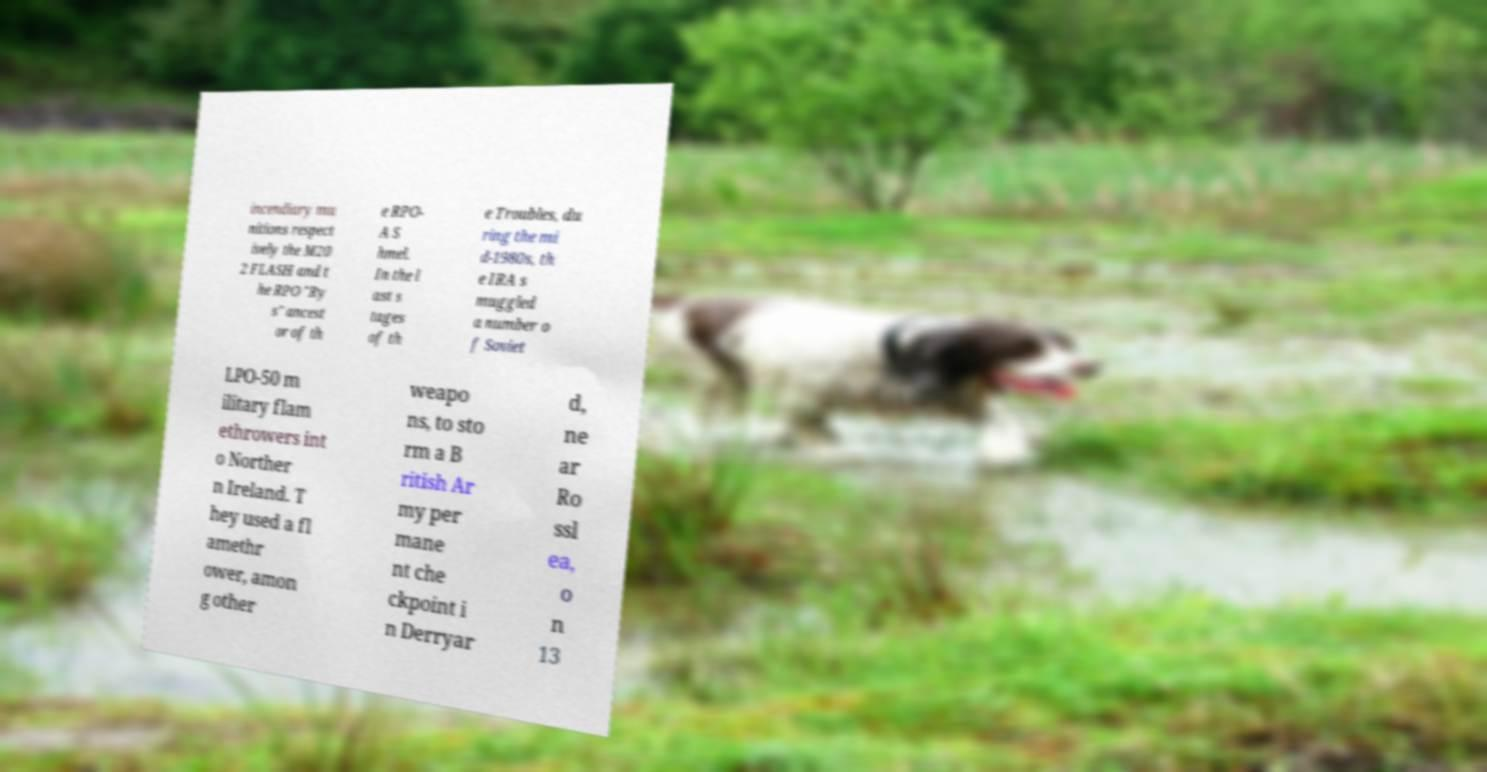Could you extract and type out the text from this image? incendiary mu nitions respect ively the M20 2 FLASH and t he RPO "Ry s" ancest or of th e RPO- A S hmel. In the l ast s tages of th e Troubles, du ring the mi d-1980s, th e IRA s muggled a number o f Soviet LPO-50 m ilitary flam ethrowers int o Norther n Ireland. T hey used a fl amethr ower, amon g other weapo ns, to sto rm a B ritish Ar my per mane nt che ckpoint i n Derryar d, ne ar Ro ssl ea, o n 13 